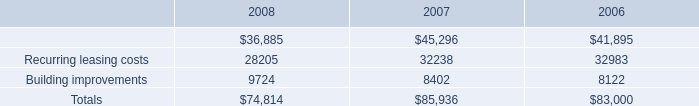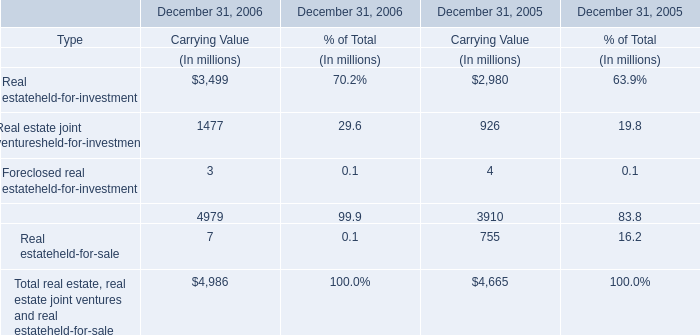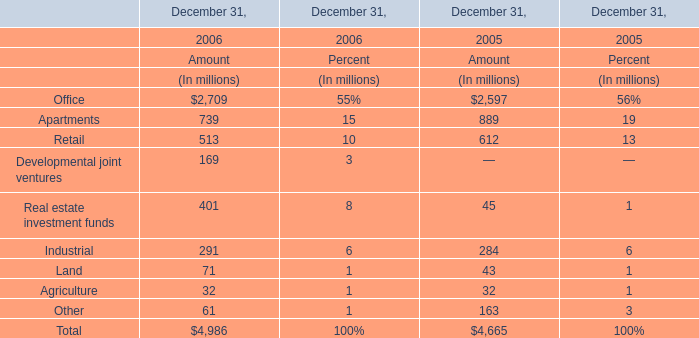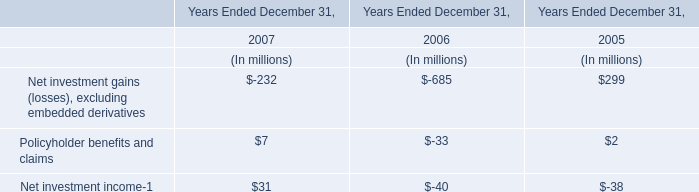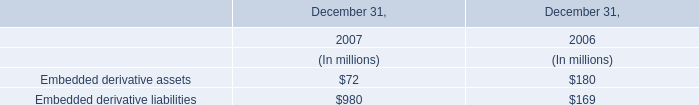If Industrial develops with the same increasing rate in 2006, what will it reach in 2007? (in million) 
Computations: ((((291 - 284) / 284) + 1) * 291)
Answer: 298.17254. 